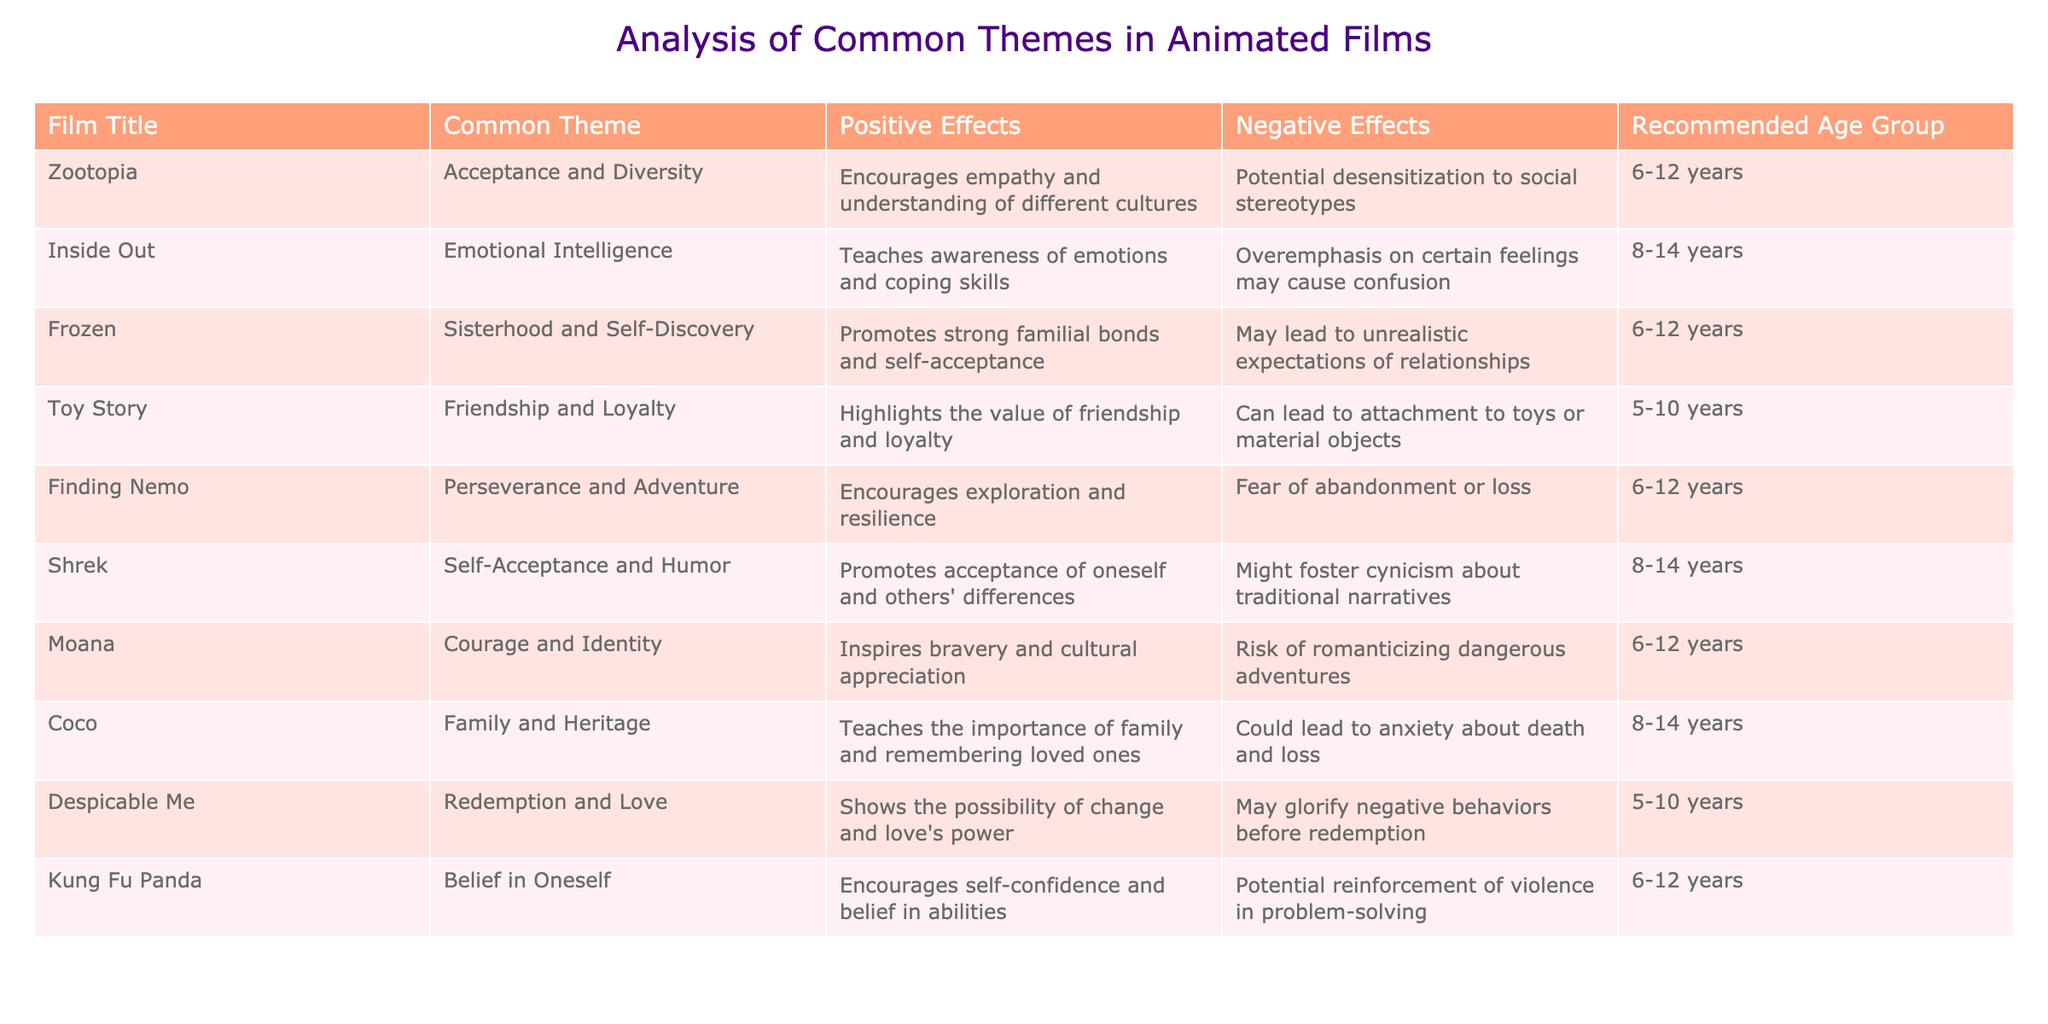What is the common theme of the film "Zootopia"? The table lists "Zootopia" under the "Common Theme" column, showing that its theme is "Acceptance and Diversity".
Answer: Acceptance and Diversity Which film focuses on "Emotional Intelligence"? By looking through the "Common Theme" column, "Inside Out" is identified as the film that focuses on "Emotional Intelligence".
Answer: Inside Out Are any films recommended for children under 5 years old? The table indicates that the recommended age groups for all films start at 5 years, so there are no films suitable for children under 5.
Answer: No What are the positive effects of watching "Finding Nemo"? The table mentions that "Finding Nemo" has a positive effect of encouraging exploration and resilience.
Answer: Encourages exploration and resilience Which film has the potential negative effect of "overemphasis on certain feelings may cause confusion"? By reviewing the "Negative Effects" column for each film, it is clear that this specific effect is attributed to "Inside Out".
Answer: Inside Out What is the average age recommendation for films that promote familial bonds like "Frozen" and "Coco"? The recommended age for "Frozen" is 6-12 years and for "Coco" is 8-14 years. The average can be calculated by taking the midpoint of each recommendation: (9 + 11) / 2 = 10. Thus, the average recommendation is 10.
Answer: 10 Is "Kung Fu Panda" associated with any negative effects? The table shows that "Kung Fu Panda" has a potential negative effect related to the reinforcement of violence in problem-solving, meaning it does have negative aspects.
Answer: Yes How many films emphasize themes of self-acceptance? Checking the "Common Theme" column, both "Shrek" and "Frozen" emphasize self-acceptance, which totals to 2 films.
Answer: 2 What are the themes of films recommended for children aged 6-12 years? By looking through the "Common Theme" column for the films recommended for children aged 6-12 years, the themes identified are "Acceptance and Diversity", "Sisterhood and Self-Discovery", "Perseverance and Adventure", "Courage and Identity", and "Belief in Oneself".
Answer: Acceptance and Diversity, Sisterhood and Self-Discovery, Perseverance and Adventure, Courage and Identity, Belief in Oneself 